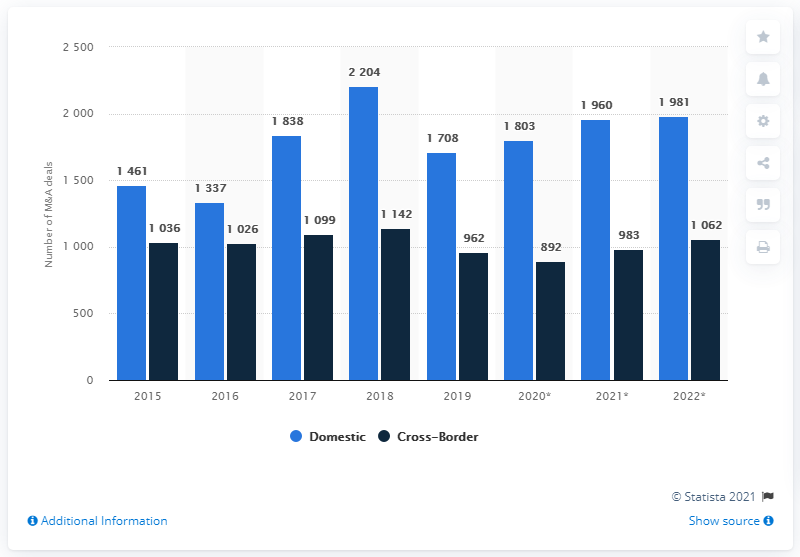Draw attention to some important aspects in this diagram. The light blue color indicates domestic origin. The difference between domestic and cross border in 2018 refers to the variation in the characteristics and circumstances of the sales and purchases of goods and services between different countries. 